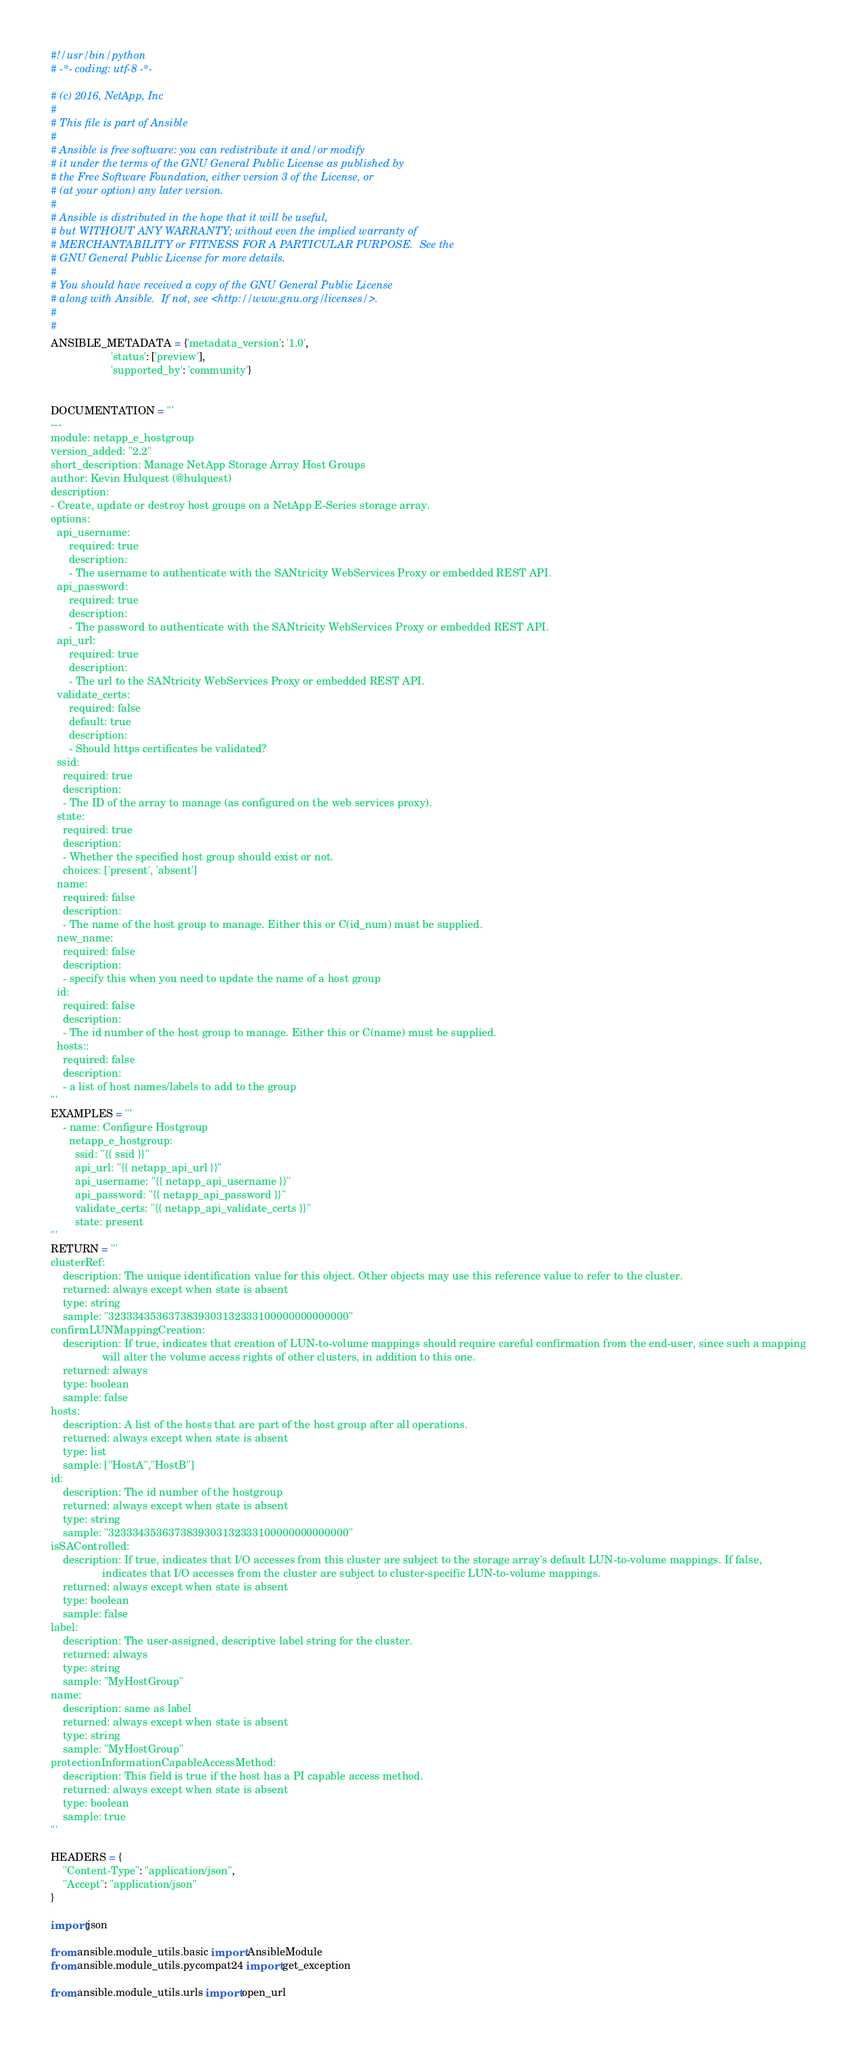<code> <loc_0><loc_0><loc_500><loc_500><_Python_>#!/usr/bin/python
# -*- coding: utf-8 -*-

# (c) 2016, NetApp, Inc
#
# This file is part of Ansible
#
# Ansible is free software: you can redistribute it and/or modify
# it under the terms of the GNU General Public License as published by
# the Free Software Foundation, either version 3 of the License, or
# (at your option) any later version.
#
# Ansible is distributed in the hope that it will be useful,
# but WITHOUT ANY WARRANTY; without even the implied warranty of
# MERCHANTABILITY or FITNESS FOR A PARTICULAR PURPOSE.  See the
# GNU General Public License for more details.
#
# You should have received a copy of the GNU General Public License
# along with Ansible.  If not, see <http://www.gnu.org/licenses/>.
#
#
ANSIBLE_METADATA = {'metadata_version': '1.0',
                    'status': ['preview'],
                    'supported_by': 'community'}


DOCUMENTATION = '''
---
module: netapp_e_hostgroup
version_added: "2.2"
short_description: Manage NetApp Storage Array Host Groups
author: Kevin Hulquest (@hulquest)
description:
- Create, update or destroy host groups on a NetApp E-Series storage array.
options:
  api_username:
      required: true
      description:
      - The username to authenticate with the SANtricity WebServices Proxy or embedded REST API.
  api_password:
      required: true
      description:
      - The password to authenticate with the SANtricity WebServices Proxy or embedded REST API.
  api_url:
      required: true
      description:
      - The url to the SANtricity WebServices Proxy or embedded REST API.
  validate_certs:
      required: false
      default: true
      description:
      - Should https certificates be validated?
  ssid:
    required: true
    description:
    - The ID of the array to manage (as configured on the web services proxy).
  state:
    required: true
    description:
    - Whether the specified host group should exist or not.
    choices: ['present', 'absent']
  name:
    required: false
    description:
    - The name of the host group to manage. Either this or C(id_num) must be supplied.
  new_name:
    required: false
    description:
    - specify this when you need to update the name of a host group
  id:
    required: false
    description:
    - The id number of the host group to manage. Either this or C(name) must be supplied.
  hosts::
    required: false
    description:
    - a list of host names/labels to add to the group
'''
EXAMPLES = '''
    - name: Configure Hostgroup
      netapp_e_hostgroup:
        ssid: "{{ ssid }}"
        api_url: "{{ netapp_api_url }}"
        api_username: "{{ netapp_api_username }}"
        api_password: "{{ netapp_api_password }}"
        validate_certs: "{{ netapp_api_validate_certs }}"
        state: present
'''
RETURN = '''
clusterRef:
    description: The unique identification value for this object. Other objects may use this reference value to refer to the cluster.
    returned: always except when state is absent
    type: string
    sample: "3233343536373839303132333100000000000000"
confirmLUNMappingCreation:
    description: If true, indicates that creation of LUN-to-volume mappings should require careful confirmation from the end-user, since such a mapping
                 will alter the volume access rights of other clusters, in addition to this one.
    returned: always
    type: boolean
    sample: false
hosts:
    description: A list of the hosts that are part of the host group after all operations.
    returned: always except when state is absent
    type: list
    sample: ["HostA","HostB"]
id:
    description: The id number of the hostgroup
    returned: always except when state is absent
    type: string
    sample: "3233343536373839303132333100000000000000"
isSAControlled:
    description: If true, indicates that I/O accesses from this cluster are subject to the storage array's default LUN-to-volume mappings. If false,
                 indicates that I/O accesses from the cluster are subject to cluster-specific LUN-to-volume mappings.
    returned: always except when state is absent
    type: boolean
    sample: false
label:
    description: The user-assigned, descriptive label string for the cluster.
    returned: always
    type: string
    sample: "MyHostGroup"
name:
    description: same as label
    returned: always except when state is absent
    type: string
    sample: "MyHostGroup"
protectionInformationCapableAccessMethod:
    description: This field is true if the host has a PI capable access method.
    returned: always except when state is absent
    type: boolean
    sample: true
'''

HEADERS = {
    "Content-Type": "application/json",
    "Accept": "application/json"
}

import json

from ansible.module_utils.basic import AnsibleModule
from ansible.module_utils.pycompat24 import get_exception

from ansible.module_utils.urls import open_url</code> 